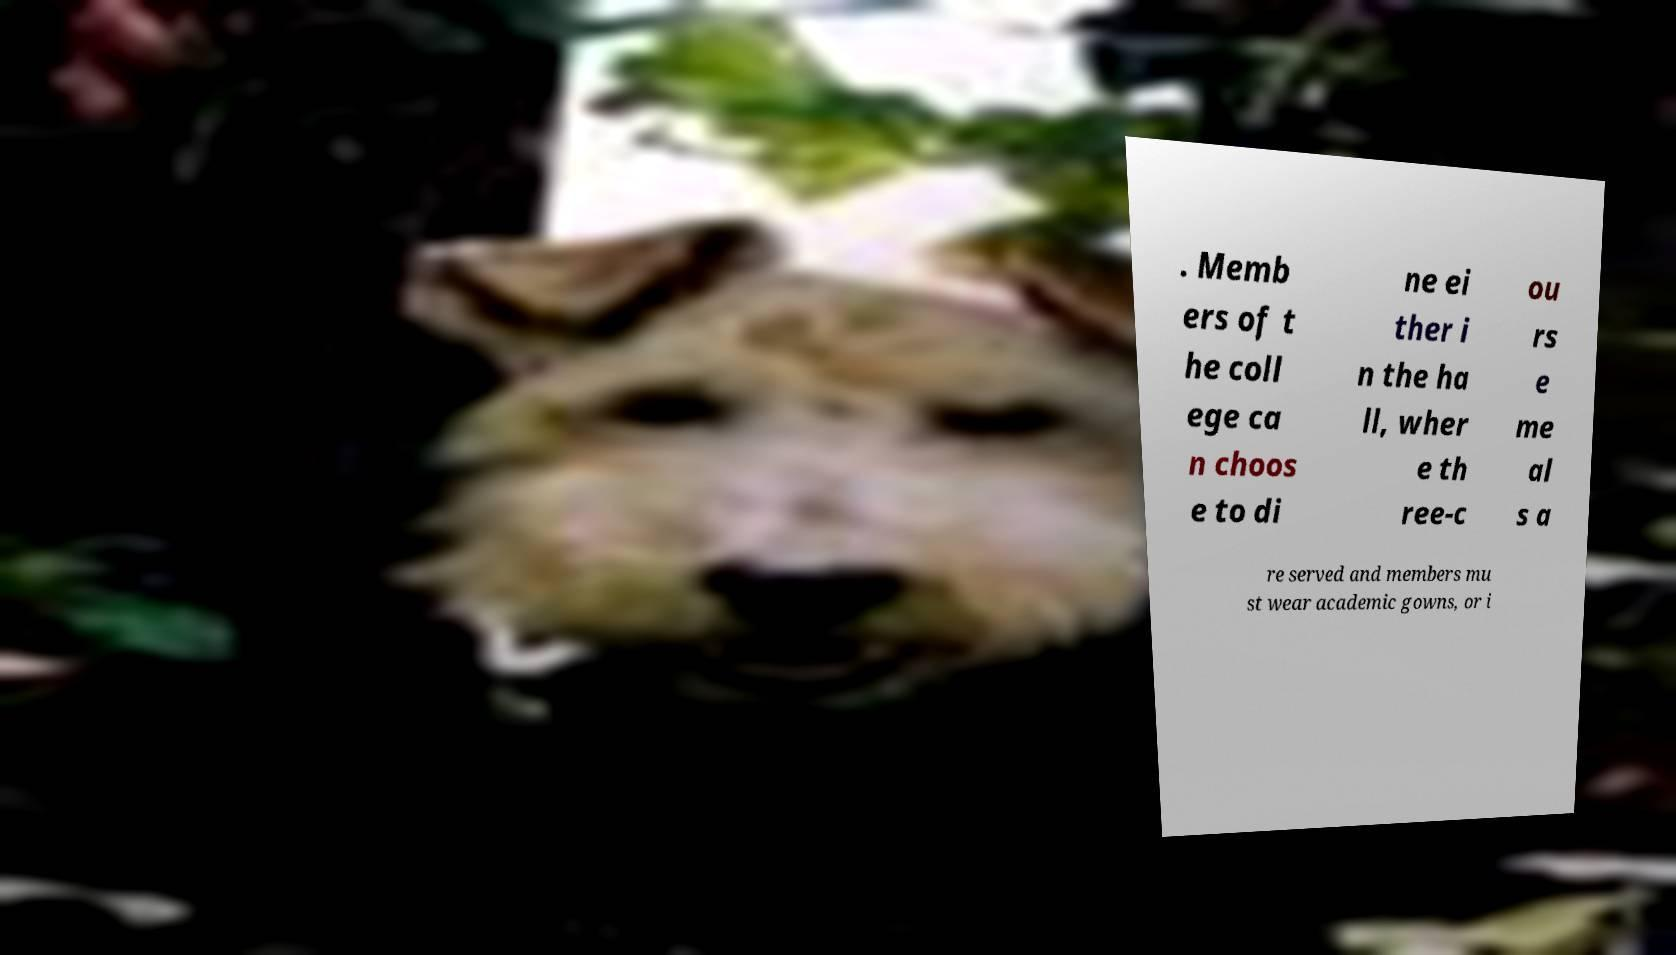There's text embedded in this image that I need extracted. Can you transcribe it verbatim? . Memb ers of t he coll ege ca n choos e to di ne ei ther i n the ha ll, wher e th ree-c ou rs e me al s a re served and members mu st wear academic gowns, or i 